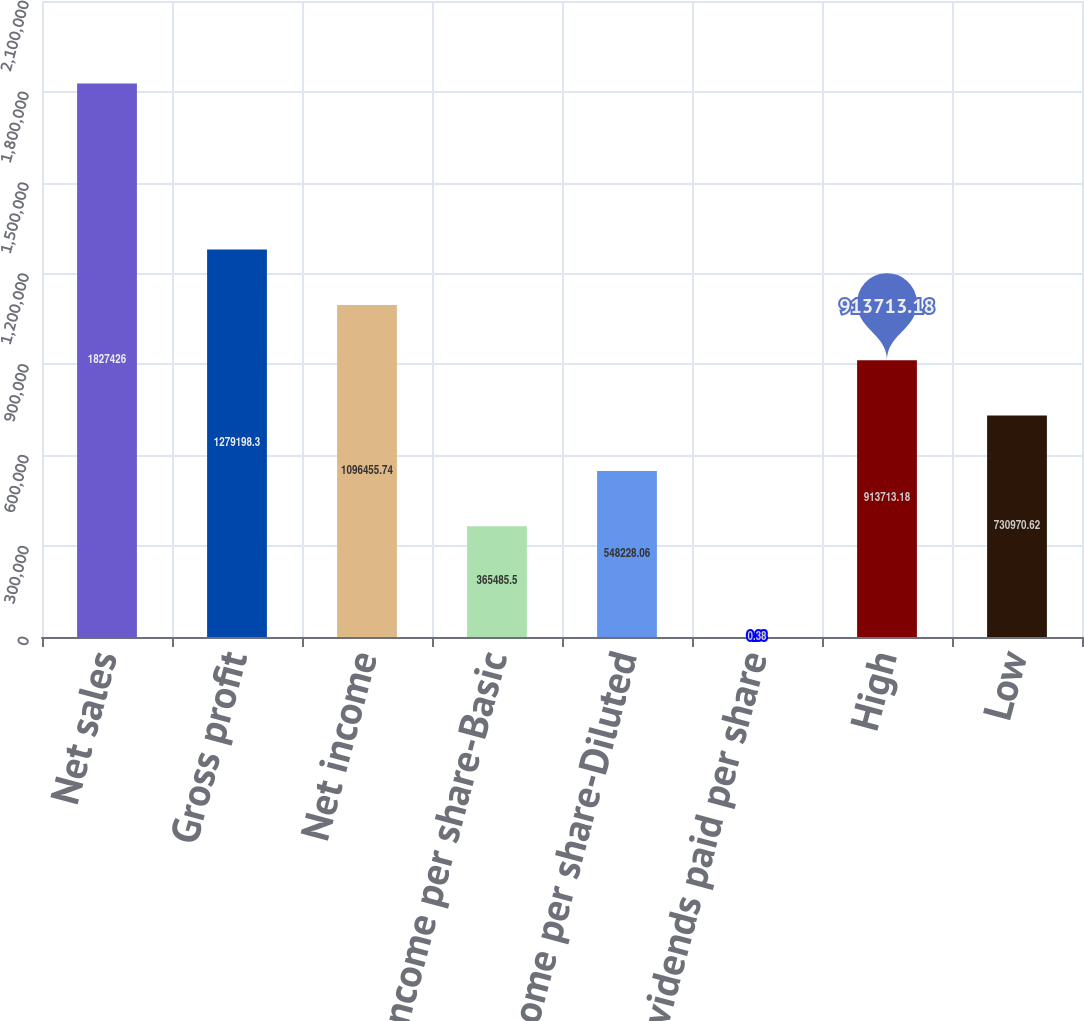Convert chart. <chart><loc_0><loc_0><loc_500><loc_500><bar_chart><fcel>Net sales<fcel>Gross profit<fcel>Net income<fcel>Net income per share-Basic<fcel>Net income per share-Diluted<fcel>Dividends paid per share<fcel>High<fcel>Low<nl><fcel>1.82743e+06<fcel>1.2792e+06<fcel>1.09646e+06<fcel>365486<fcel>548228<fcel>0.38<fcel>913713<fcel>730971<nl></chart> 